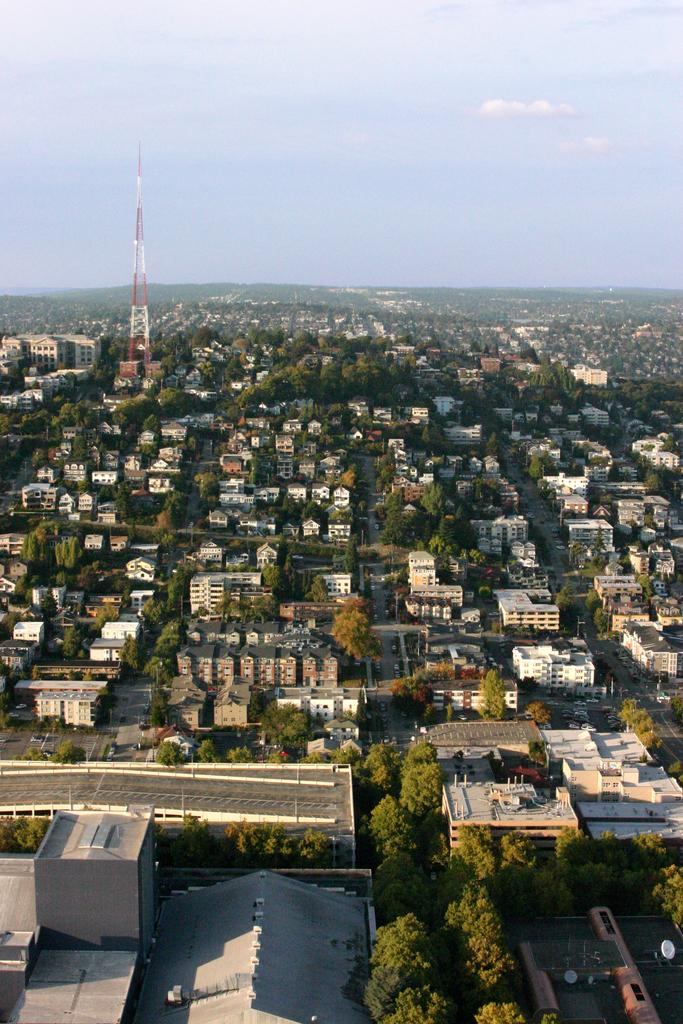What type of structures can be seen in the image? There are many buildings in the image. What other natural elements are present in the image? There are trees in the image. Can you describe a specific feature of one of the buildings? There is a tower in the image. What can be seen in the background of the image? The sky is visible in the background of the image. What is the condition of the sky in the image? Clouds are present in the sky. What type of flower is growing on the tower in the image? There is no flower growing on the tower in the image; it is a structure, not a garden. 